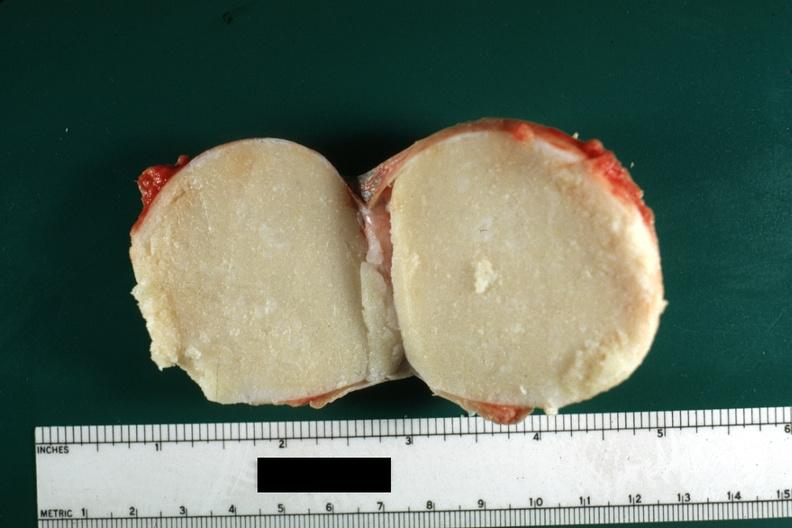was carcinoma metastatic lung from the scrotal skin?
Answer the question using a single word or phrase. No 